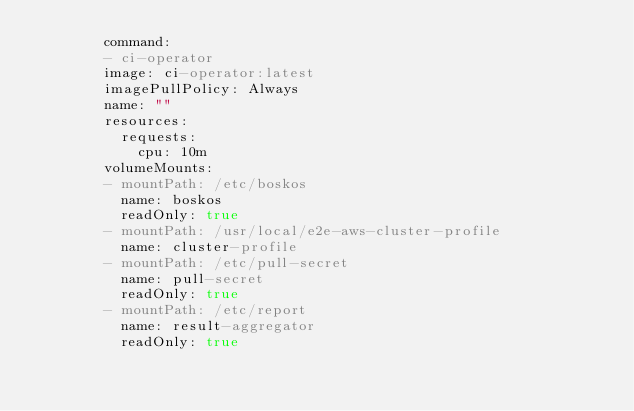Convert code to text. <code><loc_0><loc_0><loc_500><loc_500><_YAML_>        command:
        - ci-operator
        image: ci-operator:latest
        imagePullPolicy: Always
        name: ""
        resources:
          requests:
            cpu: 10m
        volumeMounts:
        - mountPath: /etc/boskos
          name: boskos
          readOnly: true
        - mountPath: /usr/local/e2e-aws-cluster-profile
          name: cluster-profile
        - mountPath: /etc/pull-secret
          name: pull-secret
          readOnly: true
        - mountPath: /etc/report
          name: result-aggregator
          readOnly: true</code> 